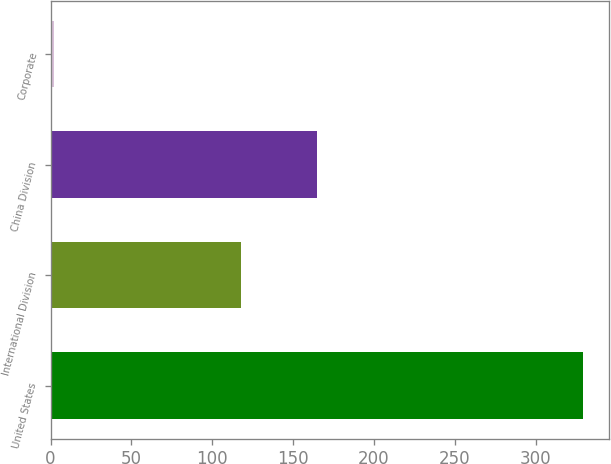Convert chart. <chart><loc_0><loc_0><loc_500><loc_500><bar_chart><fcel>United States<fcel>International Division<fcel>China Division<fcel>Corporate<nl><fcel>329<fcel>118<fcel>165<fcel>2<nl></chart> 